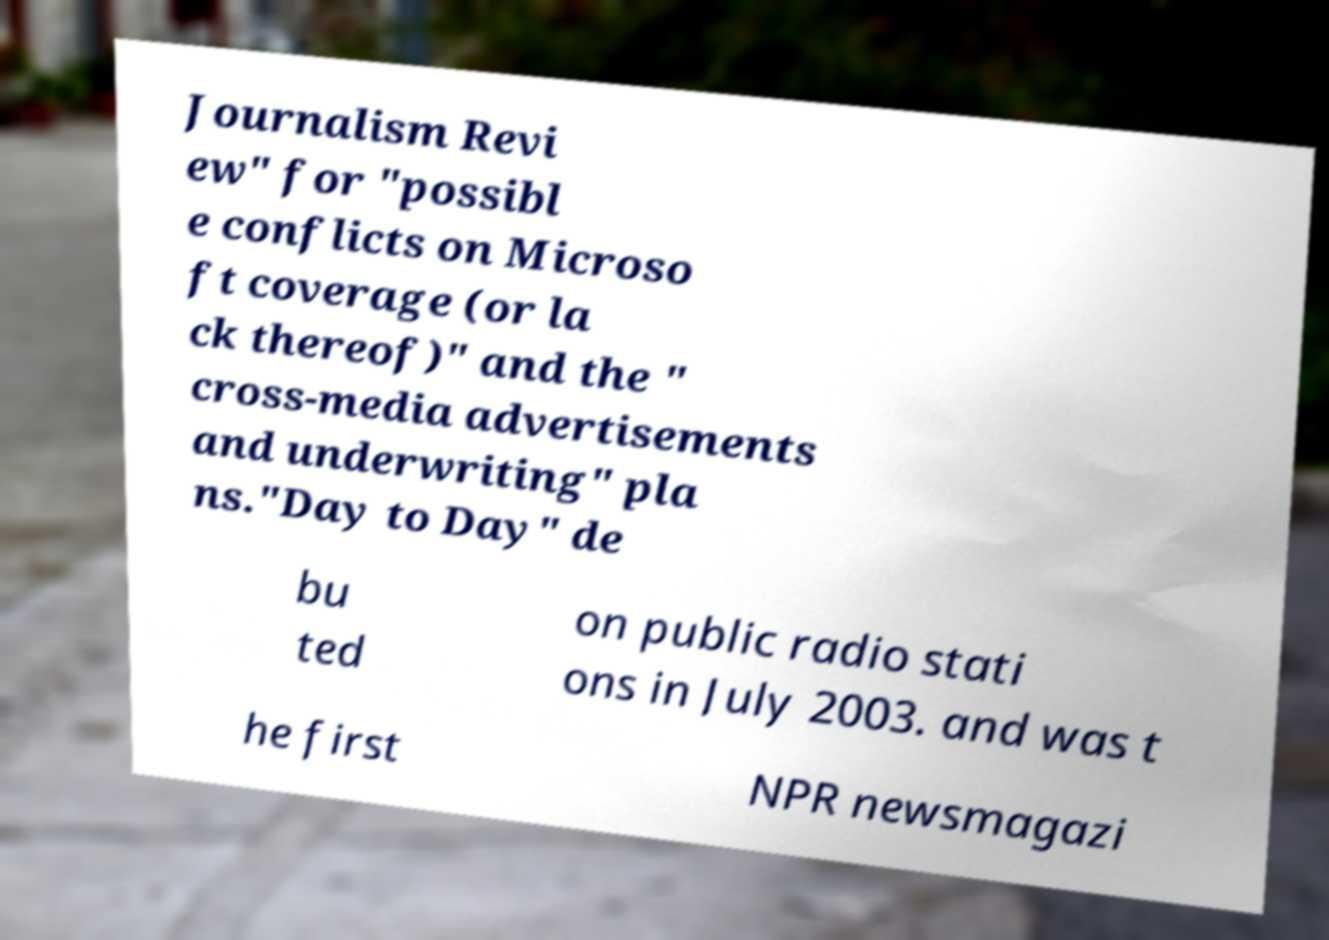Can you accurately transcribe the text from the provided image for me? Journalism Revi ew" for "possibl e conflicts on Microso ft coverage (or la ck thereof)" and the " cross-media advertisements and underwriting" pla ns."Day to Day" de bu ted on public radio stati ons in July 2003. and was t he first NPR newsmagazi 